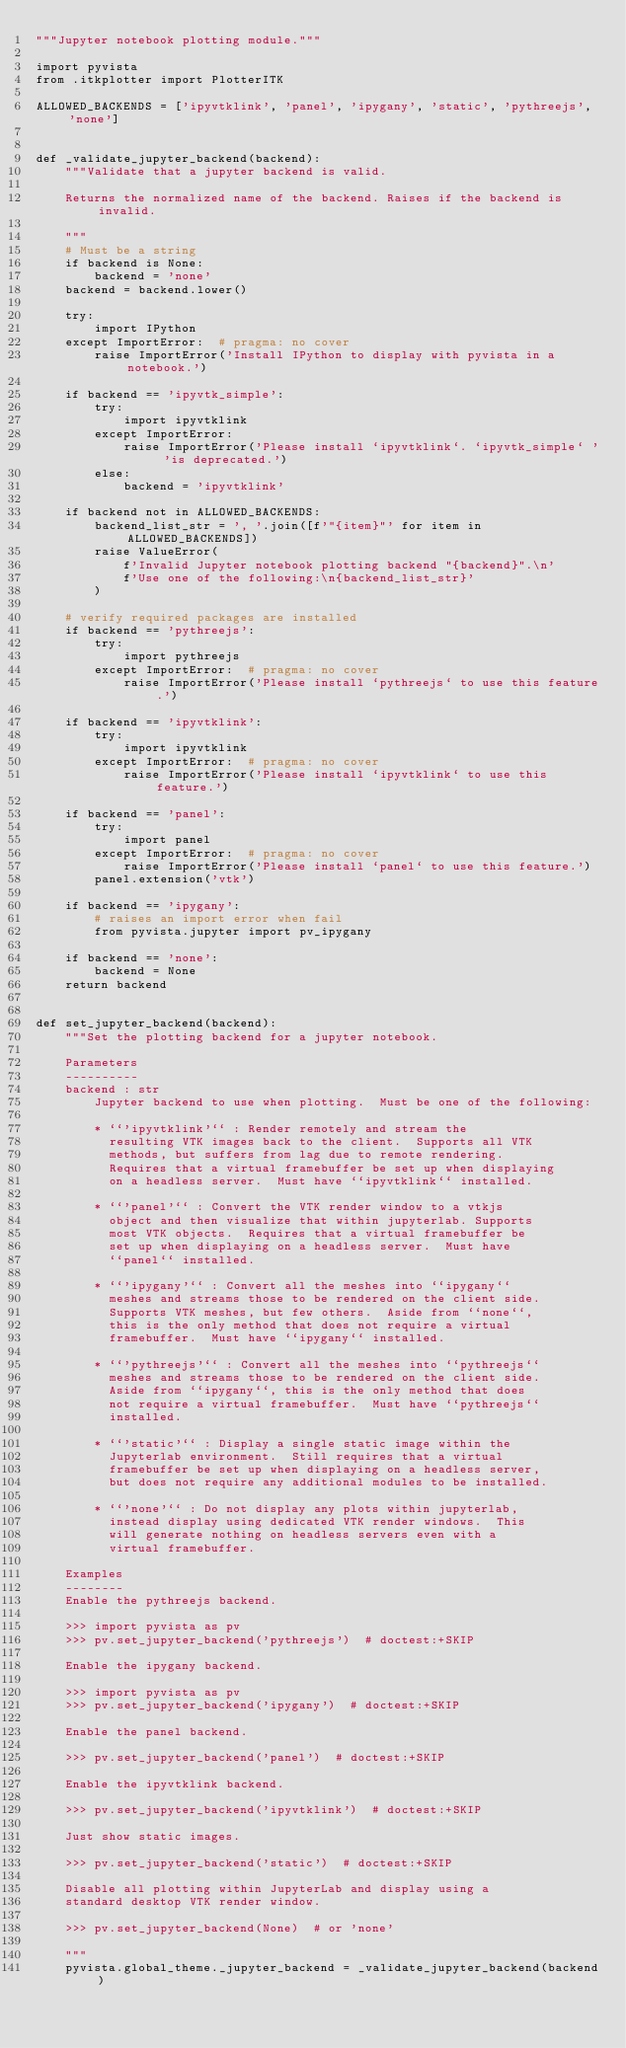Convert code to text. <code><loc_0><loc_0><loc_500><loc_500><_Python_>"""Jupyter notebook plotting module."""

import pyvista
from .itkplotter import PlotterITK

ALLOWED_BACKENDS = ['ipyvtklink', 'panel', 'ipygany', 'static', 'pythreejs', 'none']


def _validate_jupyter_backend(backend):
    """Validate that a jupyter backend is valid.

    Returns the normalized name of the backend. Raises if the backend is invalid.

    """
    # Must be a string
    if backend is None:
        backend = 'none'
    backend = backend.lower()

    try:
        import IPython
    except ImportError:  # pragma: no cover
        raise ImportError('Install IPython to display with pyvista in a notebook.')

    if backend == 'ipyvtk_simple':
        try:
            import ipyvtklink
        except ImportError:
            raise ImportError('Please install `ipyvtklink`. `ipyvtk_simple` ' 'is deprecated.')
        else:
            backend = 'ipyvtklink'

    if backend not in ALLOWED_BACKENDS:
        backend_list_str = ', '.join([f'"{item}"' for item in ALLOWED_BACKENDS])
        raise ValueError(
            f'Invalid Jupyter notebook plotting backend "{backend}".\n'
            f'Use one of the following:\n{backend_list_str}'
        )

    # verify required packages are installed
    if backend == 'pythreejs':
        try:
            import pythreejs
        except ImportError:  # pragma: no cover
            raise ImportError('Please install `pythreejs` to use this feature.')

    if backend == 'ipyvtklink':
        try:
            import ipyvtklink
        except ImportError:  # pragma: no cover
            raise ImportError('Please install `ipyvtklink` to use this feature.')

    if backend == 'panel':
        try:
            import panel
        except ImportError:  # pragma: no cover
            raise ImportError('Please install `panel` to use this feature.')
        panel.extension('vtk')

    if backend == 'ipygany':
        # raises an import error when fail
        from pyvista.jupyter import pv_ipygany

    if backend == 'none':
        backend = None
    return backend


def set_jupyter_backend(backend):
    """Set the plotting backend for a jupyter notebook.

    Parameters
    ----------
    backend : str
        Jupyter backend to use when plotting.  Must be one of the following:

        * ``'ipyvtklink'`` : Render remotely and stream the
          resulting VTK images back to the client.  Supports all VTK
          methods, but suffers from lag due to remote rendering.
          Requires that a virtual framebuffer be set up when displaying
          on a headless server.  Must have ``ipyvtklink`` installed.

        * ``'panel'`` : Convert the VTK render window to a vtkjs
          object and then visualize that within jupyterlab. Supports
          most VTK objects.  Requires that a virtual framebuffer be
          set up when displaying on a headless server.  Must have
          ``panel`` installed.

        * ``'ipygany'`` : Convert all the meshes into ``ipygany``
          meshes and streams those to be rendered on the client side.
          Supports VTK meshes, but few others.  Aside from ``none``,
          this is the only method that does not require a virtual
          framebuffer.  Must have ``ipygany`` installed.

        * ``'pythreejs'`` : Convert all the meshes into ``pythreejs``
          meshes and streams those to be rendered on the client side.
          Aside from ``ipygany``, this is the only method that does
          not require a virtual framebuffer.  Must have ``pythreejs``
          installed.

        * ``'static'`` : Display a single static image within the
          Jupyterlab environment.  Still requires that a virtual
          framebuffer be set up when displaying on a headless server,
          but does not require any additional modules to be installed.

        * ``'none'`` : Do not display any plots within jupyterlab,
          instead display using dedicated VTK render windows.  This
          will generate nothing on headless servers even with a
          virtual framebuffer.

    Examples
    --------
    Enable the pythreejs backend.

    >>> import pyvista as pv
    >>> pv.set_jupyter_backend('pythreejs')  # doctest:+SKIP

    Enable the ipygany backend.

    >>> import pyvista as pv
    >>> pv.set_jupyter_backend('ipygany')  # doctest:+SKIP

    Enable the panel backend.

    >>> pv.set_jupyter_backend('panel')  # doctest:+SKIP

    Enable the ipyvtklink backend.

    >>> pv.set_jupyter_backend('ipyvtklink')  # doctest:+SKIP

    Just show static images.

    >>> pv.set_jupyter_backend('static')  # doctest:+SKIP

    Disable all plotting within JupyterLab and display using a
    standard desktop VTK render window.

    >>> pv.set_jupyter_backend(None)  # or 'none'

    """
    pyvista.global_theme._jupyter_backend = _validate_jupyter_backend(backend)
</code> 